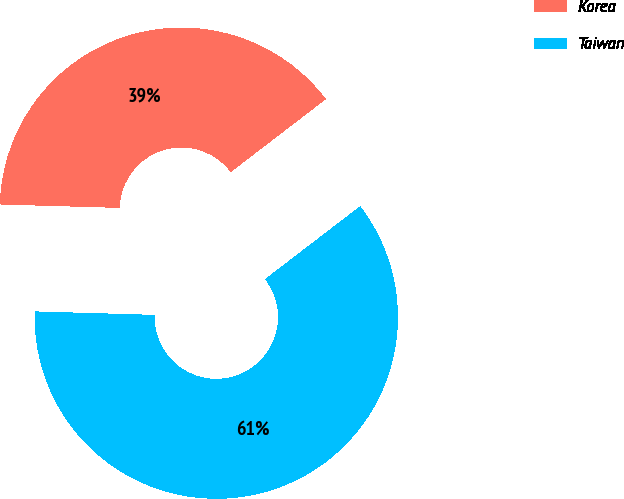Convert chart to OTSL. <chart><loc_0><loc_0><loc_500><loc_500><pie_chart><fcel>Korea<fcel>Taiwan<nl><fcel>39.13%<fcel>60.87%<nl></chart> 